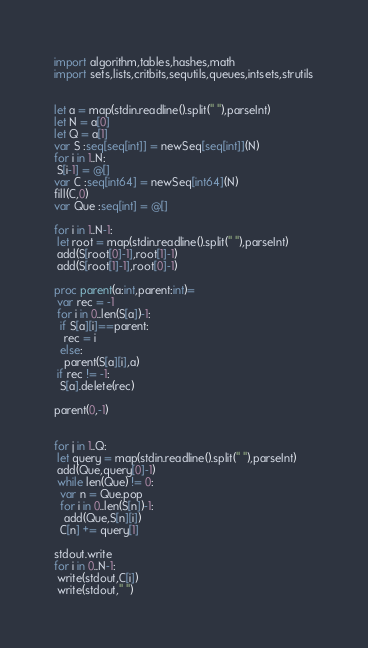Convert code to text. <code><loc_0><loc_0><loc_500><loc_500><_Nim_>import algorithm,tables,hashes,math
import sets,lists,critbits,sequtils,queues,intsets,strutils


let a = map(stdin.readline().split(" "),parseInt)
let N = a[0]
let Q = a[1]
var S :seq[seq[int]] = newSeq[seq[int]](N)
for i in 1..N:
 S[i-1] = @[]
var C :seq[int64] = newSeq[int64](N)
fill(C,0)
var Que :seq[int] = @[]

for i in 1..N-1:
 let root = map(stdin.readline().split(" "),parseInt)
 add(S[root[0]-1],root[1]-1)
 add(S[root[1]-1],root[0]-1)

proc parent(a:int,parent:int)=
 var rec = -1
 for i in 0..len(S[a])-1:
  if S[a][i]==parent:
   rec = i
  else:
   parent(S[a][i],a)
 if rec != -1:
  S[a].delete(rec)

parent(0,-1)
 

for j in 1..Q:
 let query = map(stdin.readline().split(" "),parseInt)
 add(Que,query[0]-1)
 while len(Que) != 0:
  var n = Que.pop
  for i in 0..len(S[n])-1:
   add(Que,S[n][i])
  C[n] += query[1]

stdout.write
for i in 0..N-1:
 write(stdout,C[i])
 write(stdout," ")</code> 